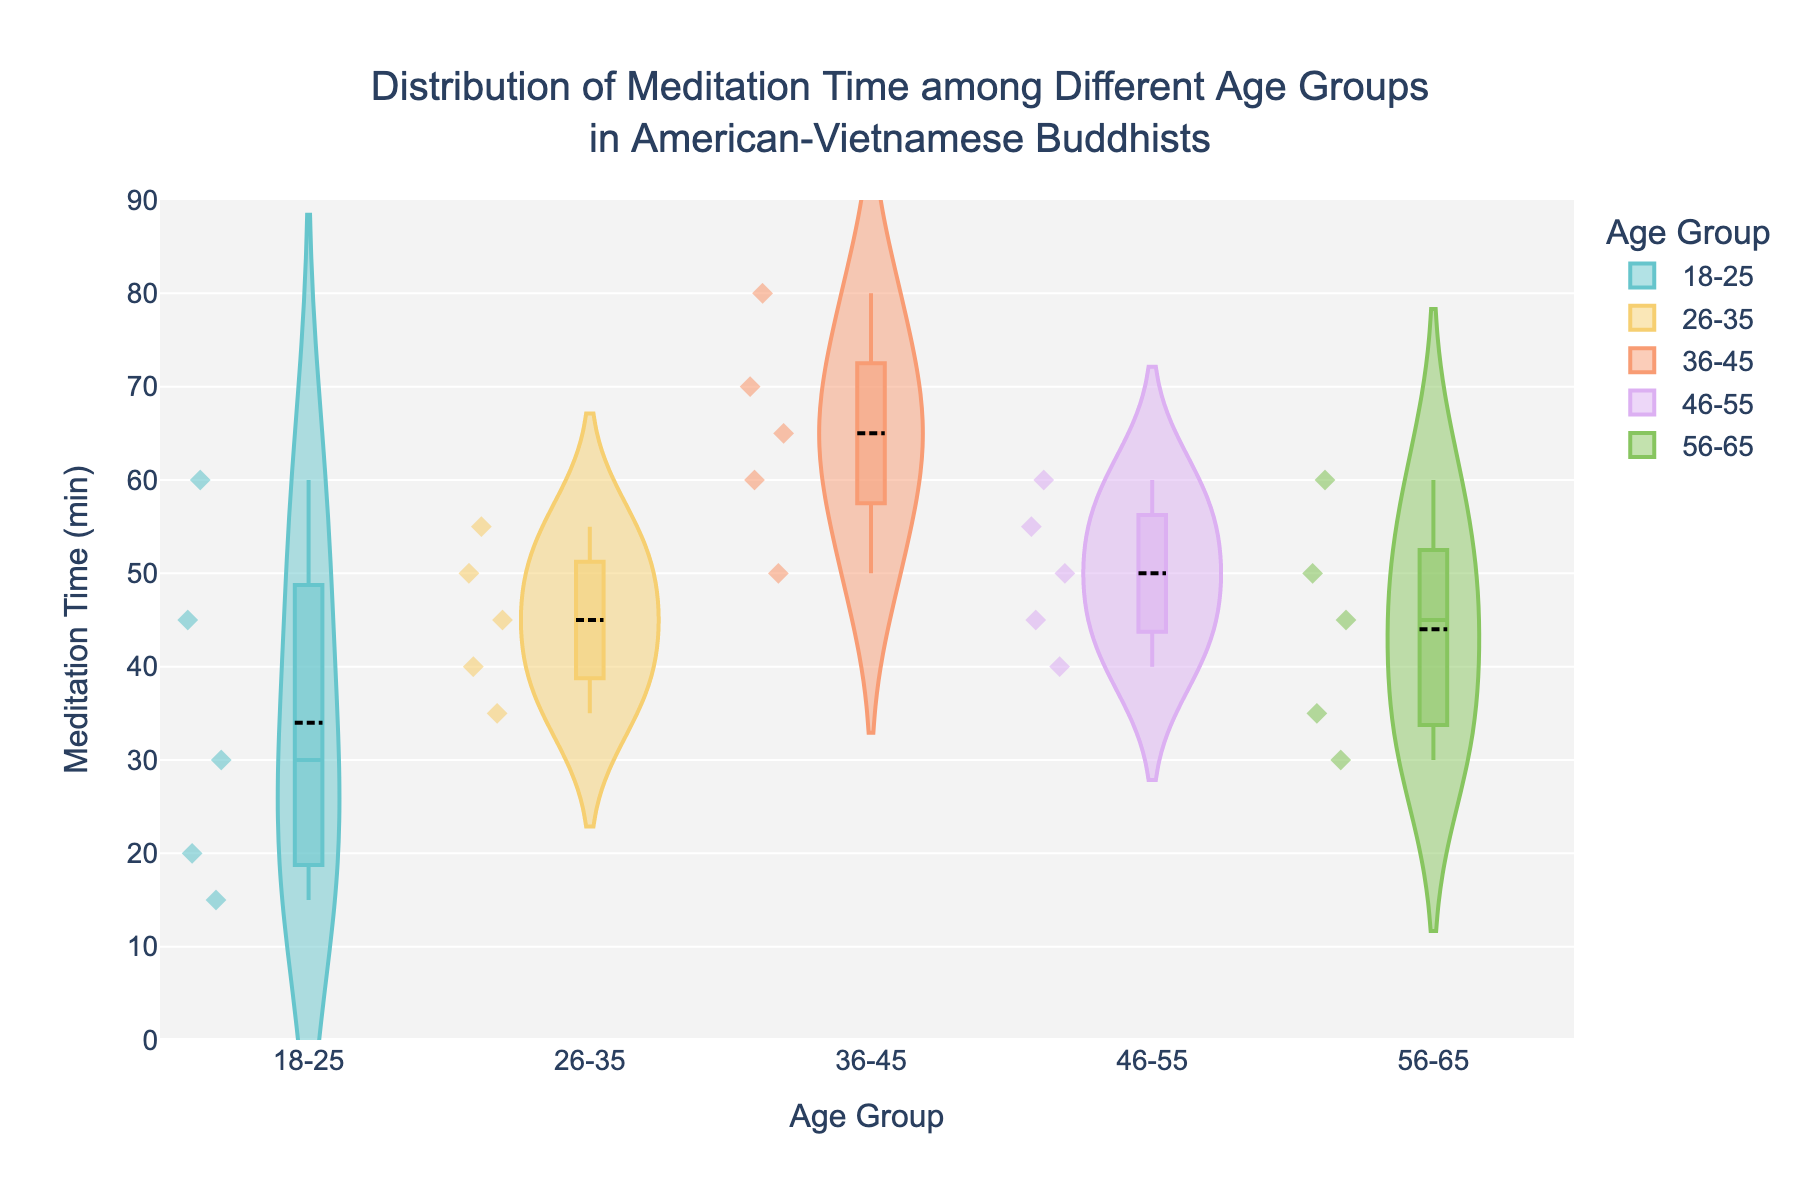What is the title of this violin chart? The title of the chart is displayed prominently and usually provides a summary of what the chart represents. The title here is "Distribution of Meditation Time among Different Age Groups in American-Vietnamese Buddhists."
Answer: Distribution of Meditation Time among Different Age Groups in American-Vietnamese Buddhists Which age group has the widest range of meditation times? By observing the spread of the violin plots, the group with the widest distribution (largest range) can be identified. The 36-45 age group has a broad spread from 50 to 80 minutes, making it the widest range.
Answer: 36-45 Which age group shows the highest median meditation time? The median value is represented by a line inside the box within the violin plot. By examining these lines, the 36-45 age group has the highest median value closer to 65 minutes.
Answer: 36-45 How many age groups are displayed in the violin chart? The x-axis categories or labels represent different age groups. By counting these categories, we see there are five groups: 18-25, 26-35, 36-45, 46-55, and 56-65.
Answer: 5 What is the median meditation time for the 18-25 age group? The median value for the 18-25 age group is represented by a line inside the box within the 18-25 violin plot. This line is at 30 minutes.
Answer: 30 minutes Which age group has the least variation in meditation time? Variation is indicated by the spread of the violin plot. The group with the tightest or narrowest range in the violin plot indicates the least variation. The 26-35 age group appears to have the least variation, as its range is relatively narrow.
Answer: 26-35 What is the approximate range of values for the 46-55 age group? By looking at the spread of the violin plot for the 46-55 age group, it ranges from approximately 40 to 60 minutes.
Answer: 40 to 60 minutes How does the mean meditation time for the 56-65 age group compare to the mean meditation time for the 18-25 age group? The mean line (horizontal line) is visible within each violin plot. Comparing these lines, the mean for the 56-65 group appears higher than the 18-25 group, which has a mean around the level of the median, but slightly higher at around 44 minutes compared to 34 in the 18-25 group.
Answer: Higher What insights does the box plot within each violin provide? Each box plot (embedded within the violin plot) shows the interquartile range (IQR) and median for each age group, providing insight into data central tendency and spread. The width of boxes shows variability, and the central line represents the median. This helps identify which age groups have more concentrated times around their medians.
Answer: The box plot provides median and IQR, showing central concentration Is there any age group where outliers are more prominent? Outliers are represented by individual points outside the main body of the violin plot. The 18-25 age group has a few prominent outliers with meditation times around 60 minutes, making them more noticeable.
Answer: 18-25 